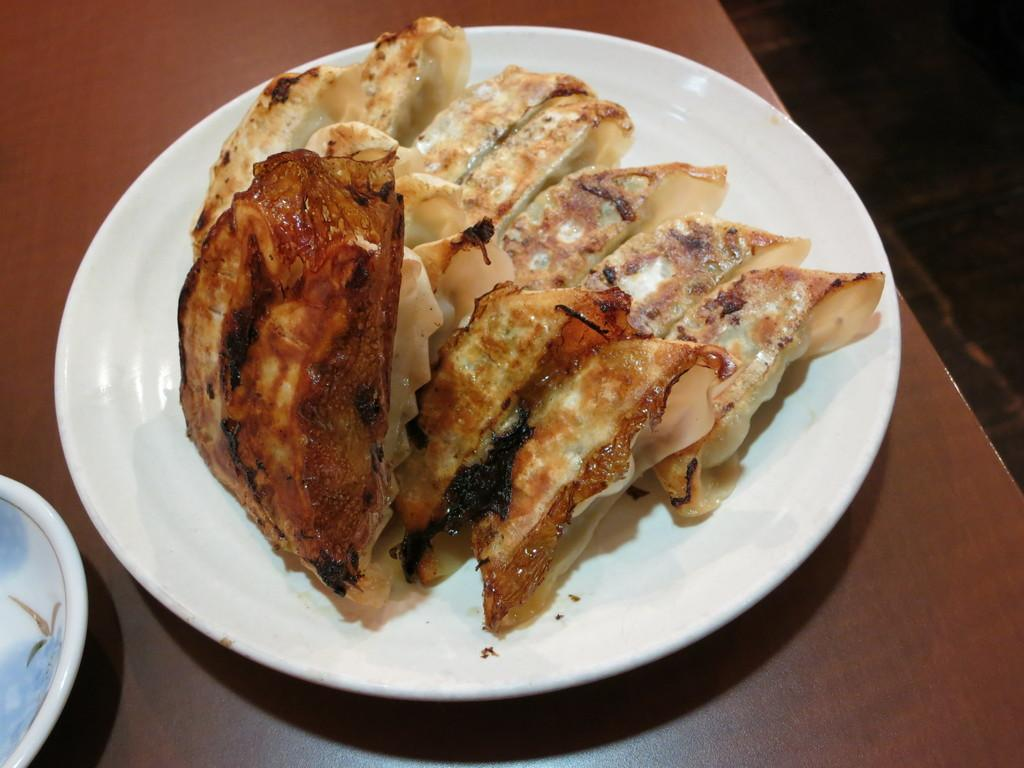What type of surface is visible in the image? There is a wooden surface in the image. What is placed on the wooden surface? There is a plate on the wooden surface. What color is the plate? The plate is white in color. What is on the plate? There is a food item in the plate. What other dish is present in the image? There is a bowl in the image. What type of sign can be seen hanging above the food item in the image? There is no sign present in the image; it only features a wooden surface, a plate, a bowl, and a food item. 